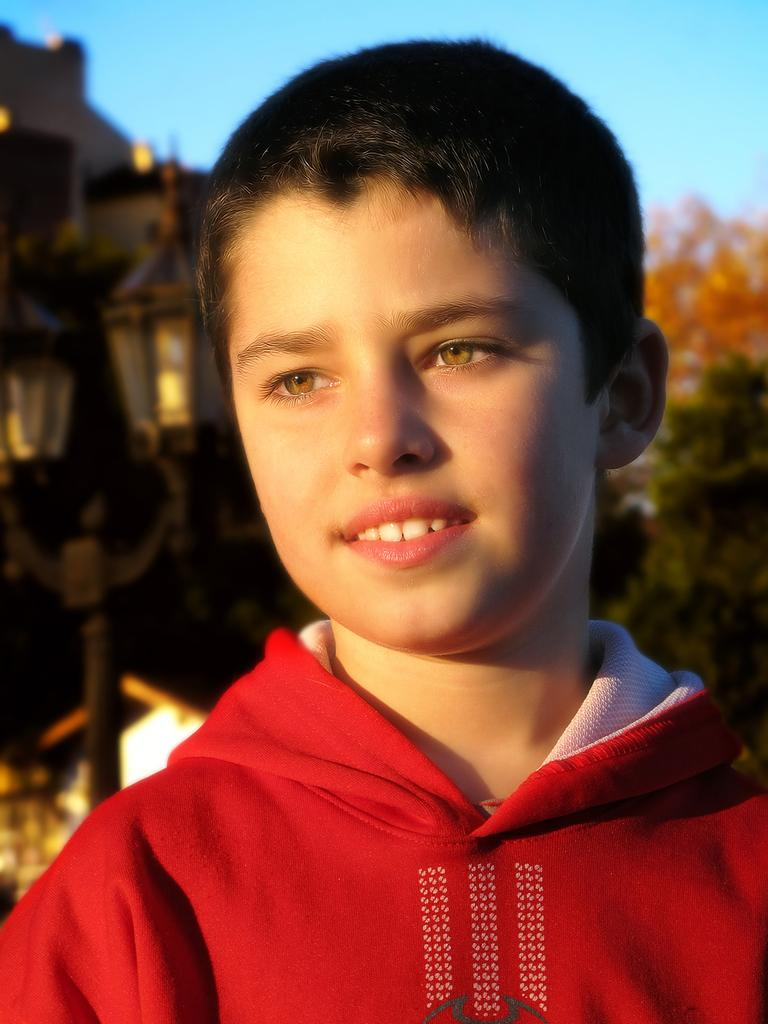Who is the main subject in the image? There is a boy in the image. What can be seen in the background of the image? There is a light pole, the sky, and trees visible in the background of the image. How would you describe the quality of the background in the image? The background of the image appears blurry. What type of soap is the boy using to wash his wrist in the image? There is no soap or wrist-washing activity present in the image. 